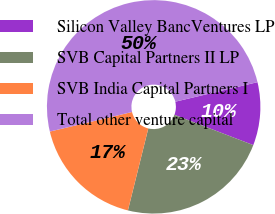Convert chart. <chart><loc_0><loc_0><loc_500><loc_500><pie_chart><fcel>Silicon Valley BancVentures LP<fcel>SVB Capital Partners II LP<fcel>SVB India Capital Partners I<fcel>Total other venture capital<nl><fcel>9.55%<fcel>23.04%<fcel>17.4%<fcel>50.0%<nl></chart> 